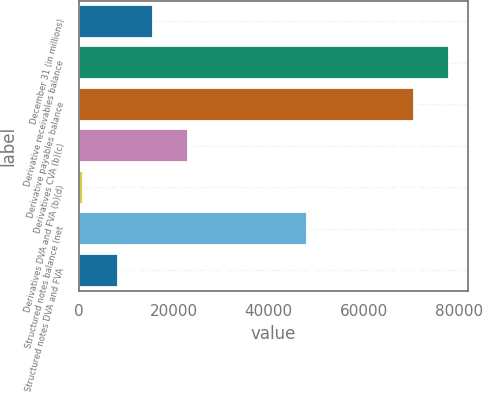<chart> <loc_0><loc_0><loc_500><loc_500><bar_chart><fcel>December 31 (in millions)<fcel>Derivative receivables balance<fcel>Derivative payables balance<fcel>Derivatives CVA (b)(c)<fcel>Derivatives DVA and FVA (b)(d)<fcel>Structured notes balance (net<fcel>Structured notes DVA and FVA<nl><fcel>15660.6<fcel>78071.3<fcel>70656<fcel>23075.9<fcel>830<fcel>48112<fcel>8245.3<nl></chart> 